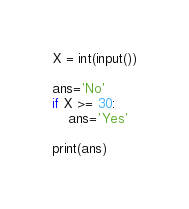Convert code to text. <code><loc_0><loc_0><loc_500><loc_500><_Python_>X = int(input())

ans='No'
if X >= 30:
    ans='Yes'
    
print(ans)
</code> 